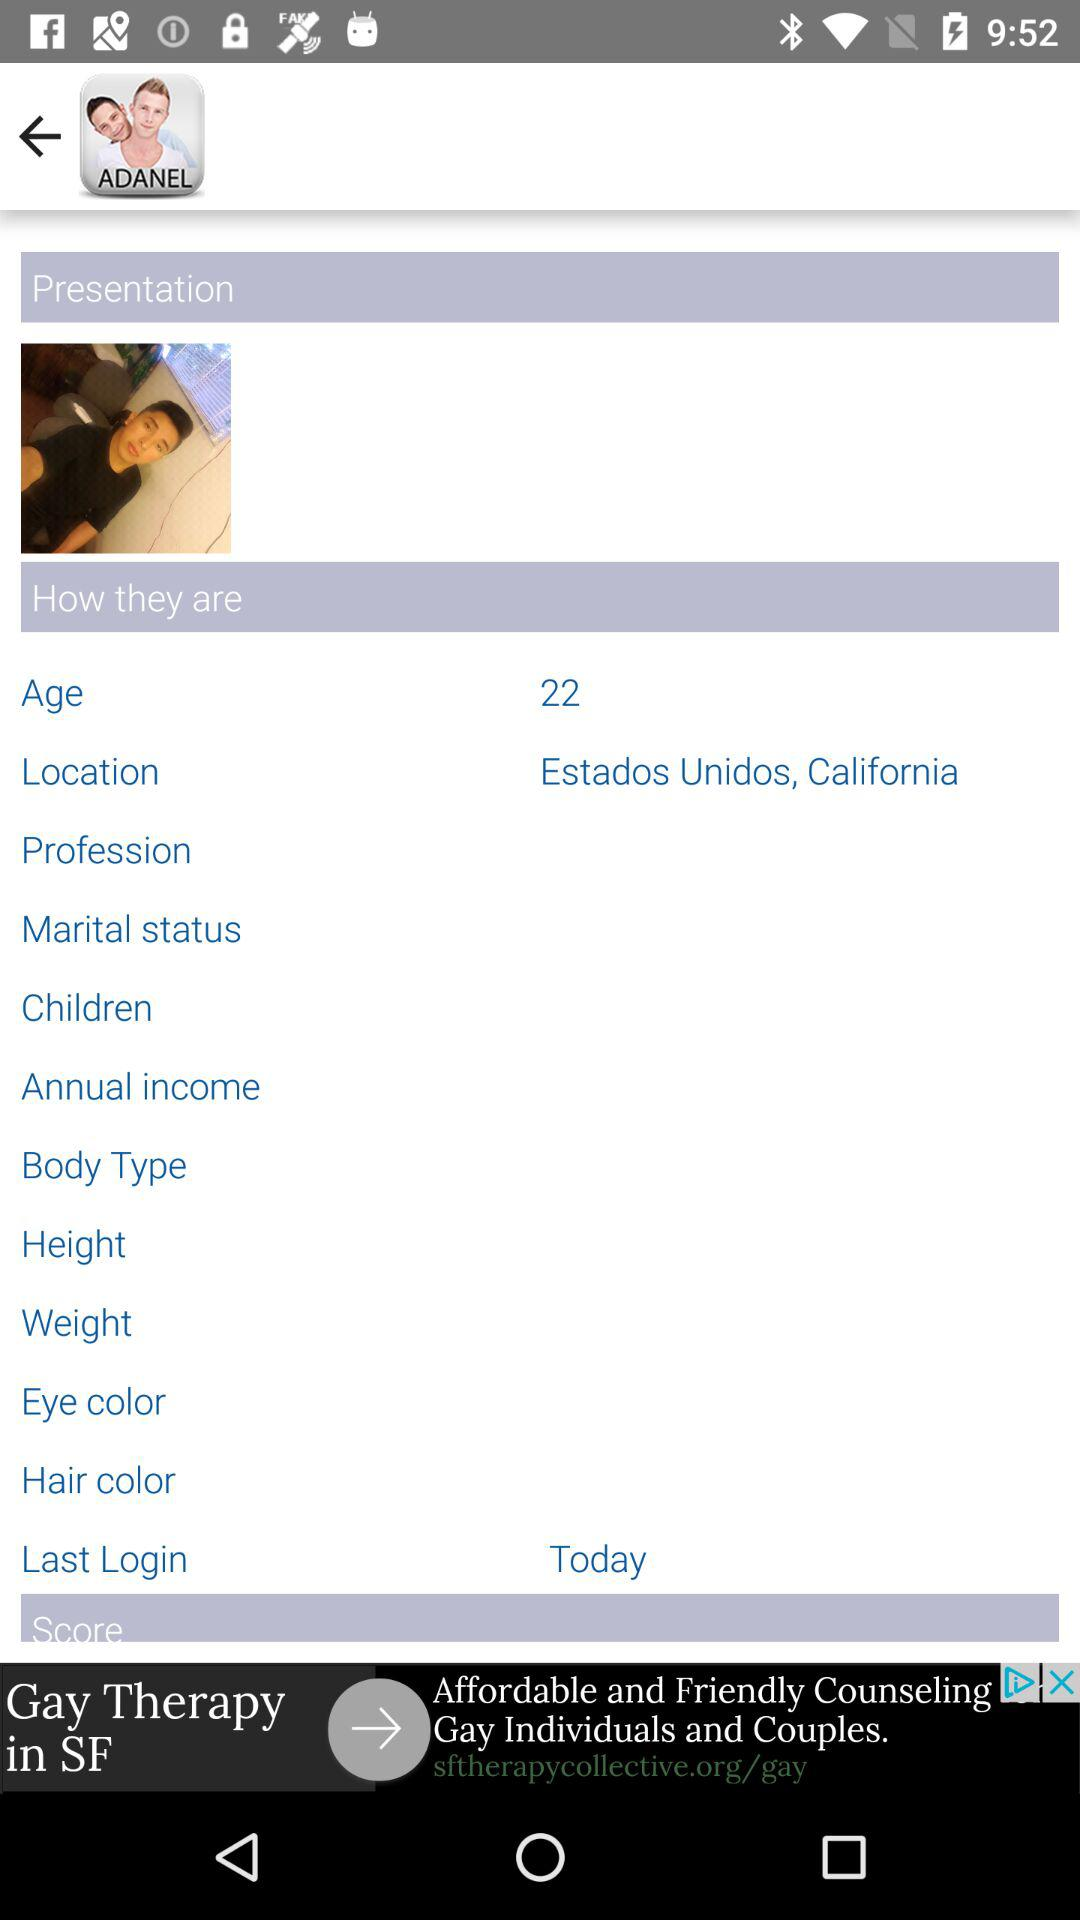What is the location? The location is Estados Unidos, California. 